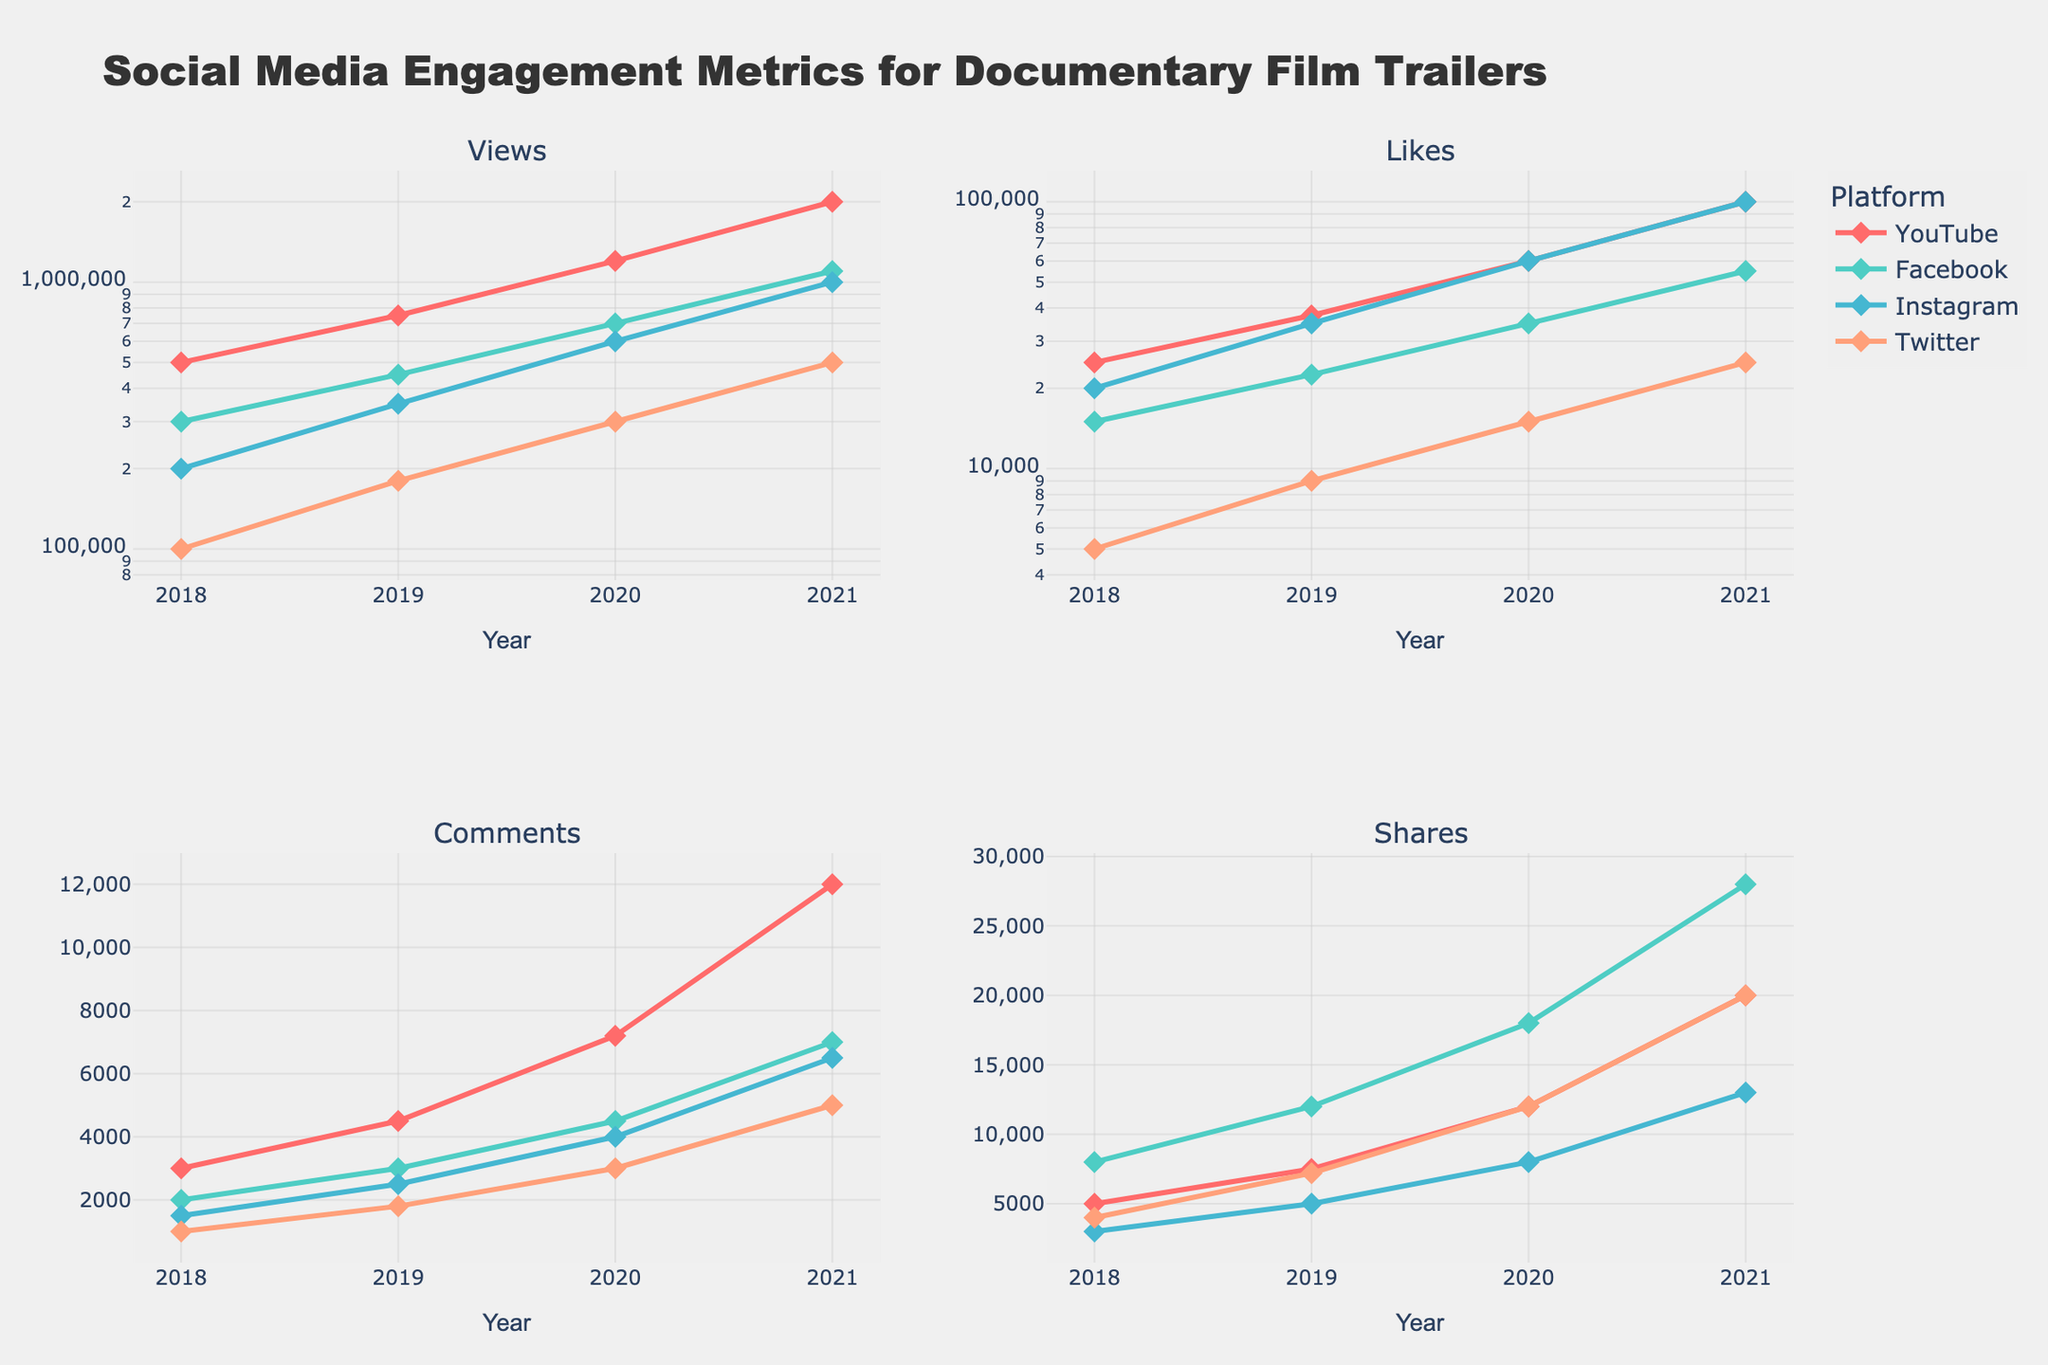Which platform had the highest number of views in 2021? To determine the platform with the highest views in 2021, we look at the "Views" values for each platform in that year. By comparing them, we find that YouTube leads with 2,000,000 views.
Answer: YouTube By how much did Facebook's shares increase from 2018 to 2021? To calculate the increase, we subtract Facebook's shares in 2018 (8,000) from its shares in 2021 (28,000). The result is 28,000 - 8,000 = 20,000.
Answer: 20,000 What's the average number of comments across all platforms in 2020? We find the comments number for all platforms in 2020: YouTube (7,200), Facebook (4,500), Instagram (4,000), and Twitter (3,000). Sum these values and divide by the number of platforms: (7,200 + 4,500 + 4,000 + 3,000) / 4 = 18,700 / 4, which equals 4,675.
Answer: 4,675 Which platform had the least increase in likes from 2018 to 2021? We calculate the increase in likes for each platform: 
YouTube: 100,000 - 25,000 = 75,000,
Facebook: 55,000 - 15,000 = 40,000,
Instagram: 100,000 - 20,000 = 80,000,
Twitter: 25,000 - 5,000 = 20,000.
Comparing these, Twitter had the smallest increase of 20,000 likes.
Answer: Twitter How many platforms had more than double the number of views in 2020 compared to 2019? We calculate if the views in 2020 are more than twice those in 2019 for each platform:
YouTube: 1,200,000 > 2 * 750,000 (False),
Facebook: 700,000 > 2 * 450,000 (False),
Instagram: 600,000 > 2 * 350,000 (False),
Twitter: 300,000 > 2 * 180,000 (False).
None of the platforms doubled their views.
Answer: 0 Which metric showed the most consistent increase across all platforms from 2018 to 2021? We observe the trends of metrics across all platforms from the figure. Comments showed a relatively consistent increase across all platforms without any large disturbances.
Answer: Comments 